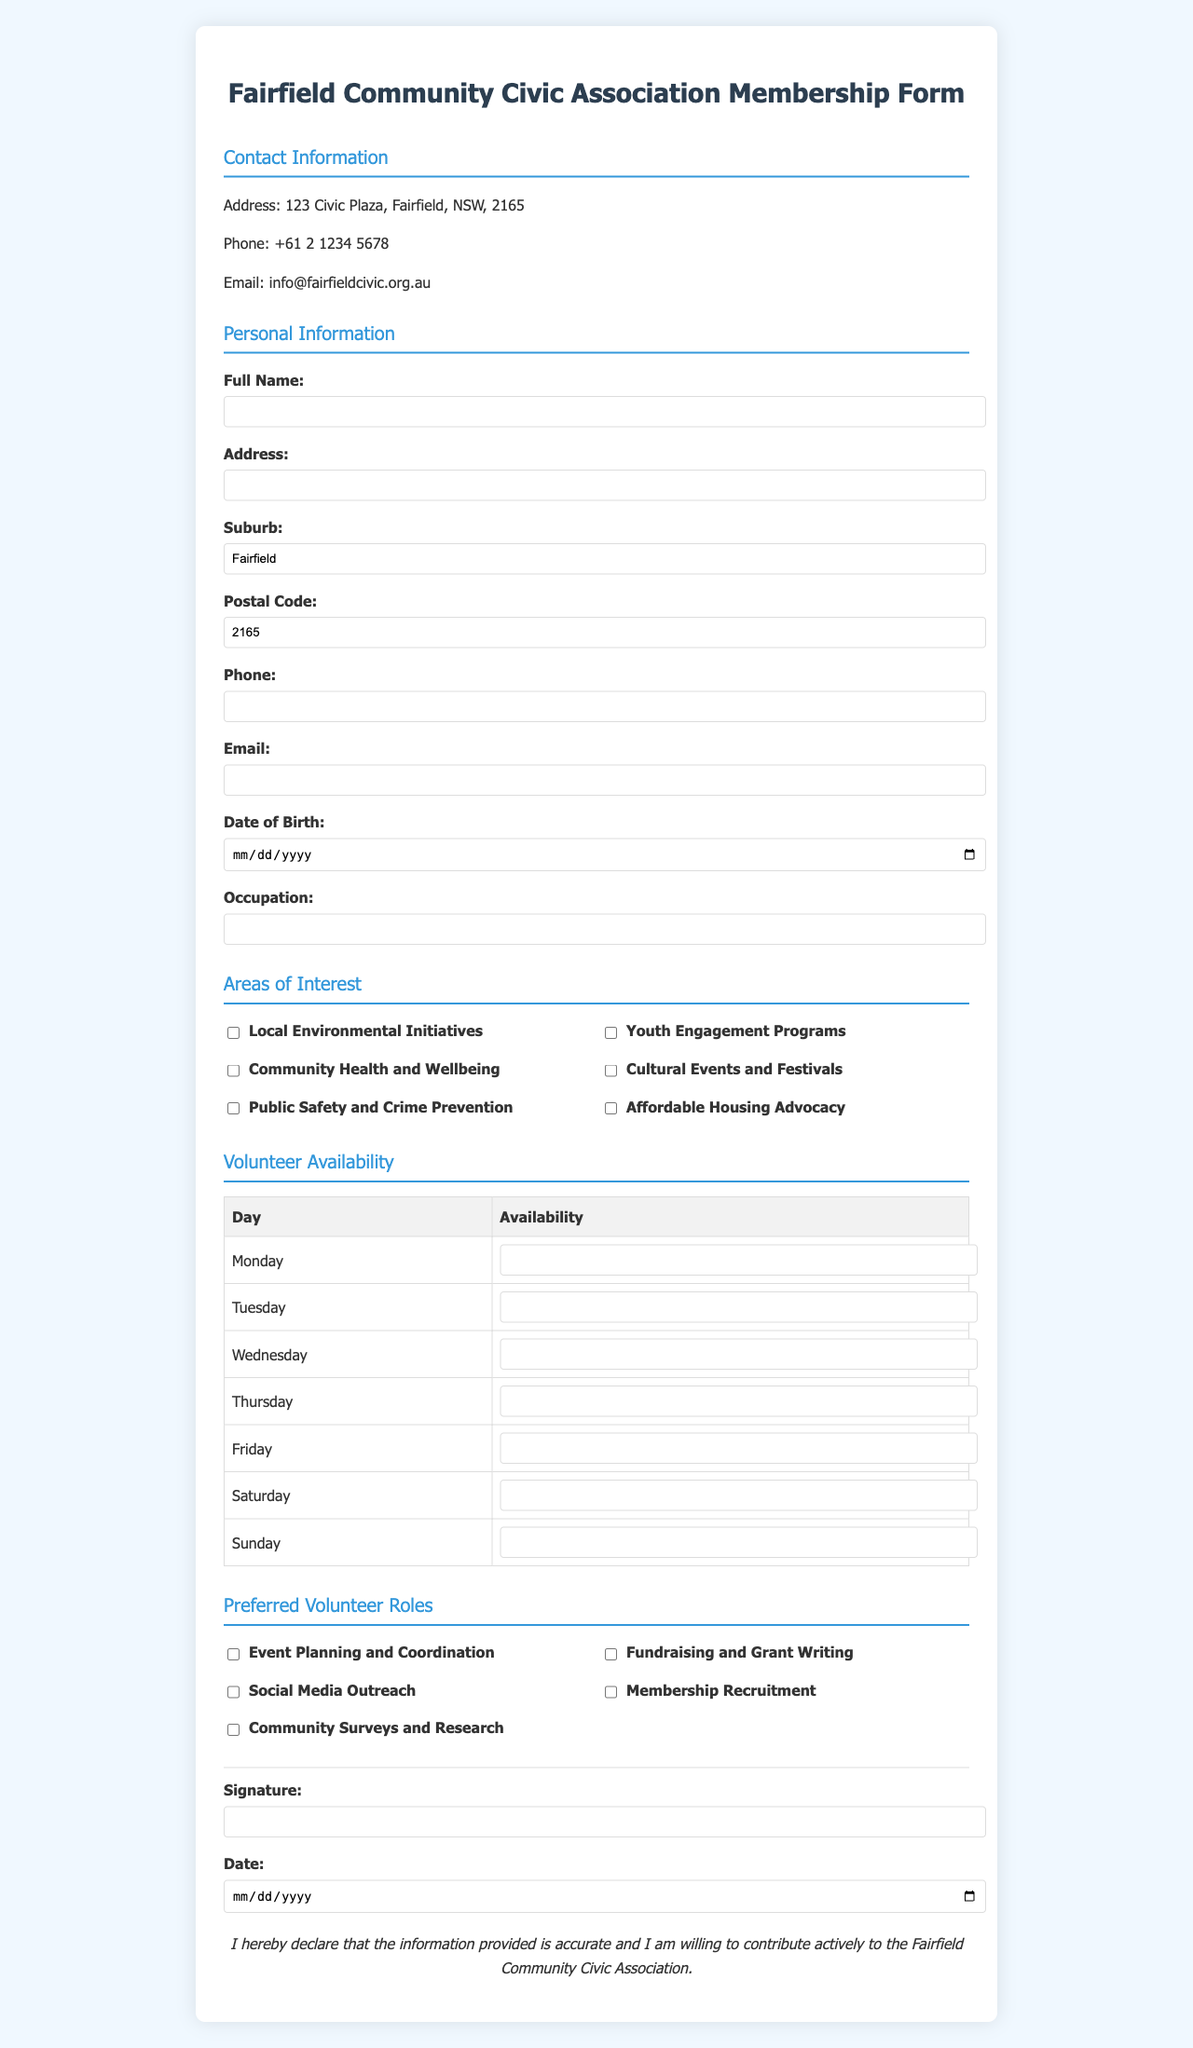what is the title of the document? The title of the document is displayed prominently at the top of the page.
Answer: Fairfield Community Civic Association Membership Form what is the address provided on the form? The address is listed in the Contact Information section of the document.
Answer: 123 Civic Plaza, Fairfield, NSW, 2165 what is the email address for the Fairfield Community Civic Association? The email address is located in the Contact Information section.
Answer: info@fairfieldcivic.org.au what is one area of interest that a member can choose? The Areas of Interest section lists various activities in which members can express interest.
Answer: Local Environmental Initiatives what is the occupation input field? The document includes an input field specifically for the applicant's job title or profession.
Answer: Occupation which day of the week asks for availability in the document? The volunteer availability section includes a table for each day of the week.
Answer: Monday what is the purpose of the signature line section? The signature line section is meant for the applicant's agreement and acknowledgment of their information's accuracy.
Answer: To provide agreement how many volunteer roles can a member select? The Preferred Volunteer Roles section lists multiple roles, indicating the number available for selection.
Answer: Five when is the date required to be provided? The document requires a date in the signature line section to confirm the application.
Answer: On the signature line how should the information provided be verified? The document contains a statement at the bottom affirming the accuracy of the information submitted.
Answer: By declaration 